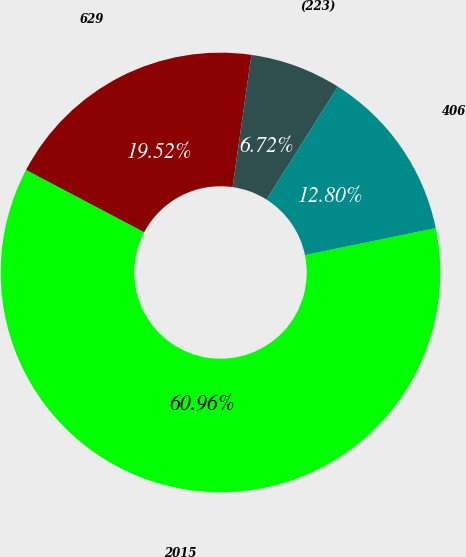Convert chart. <chart><loc_0><loc_0><loc_500><loc_500><pie_chart><fcel>2015<fcel>629<fcel>(223)<fcel>406<nl><fcel>60.96%<fcel>19.52%<fcel>6.72%<fcel>12.8%<nl></chart> 